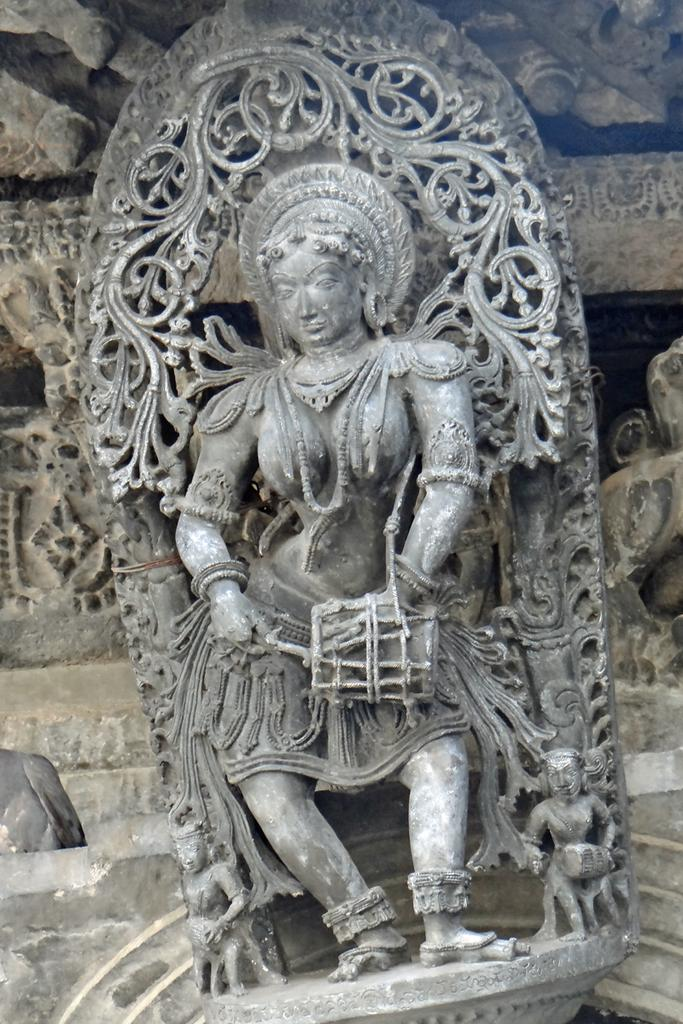What is the main subject of the image? There is a sculpture of a woman in the image. Can you describe the background of the image? There are carvings on stones in the background of the image. What type of income can be seen in the image? There is no reference to income in the image; it features a sculpture of a woman and carvings on stones. Is there a throne present in the image? There is no throne visible in the image. 